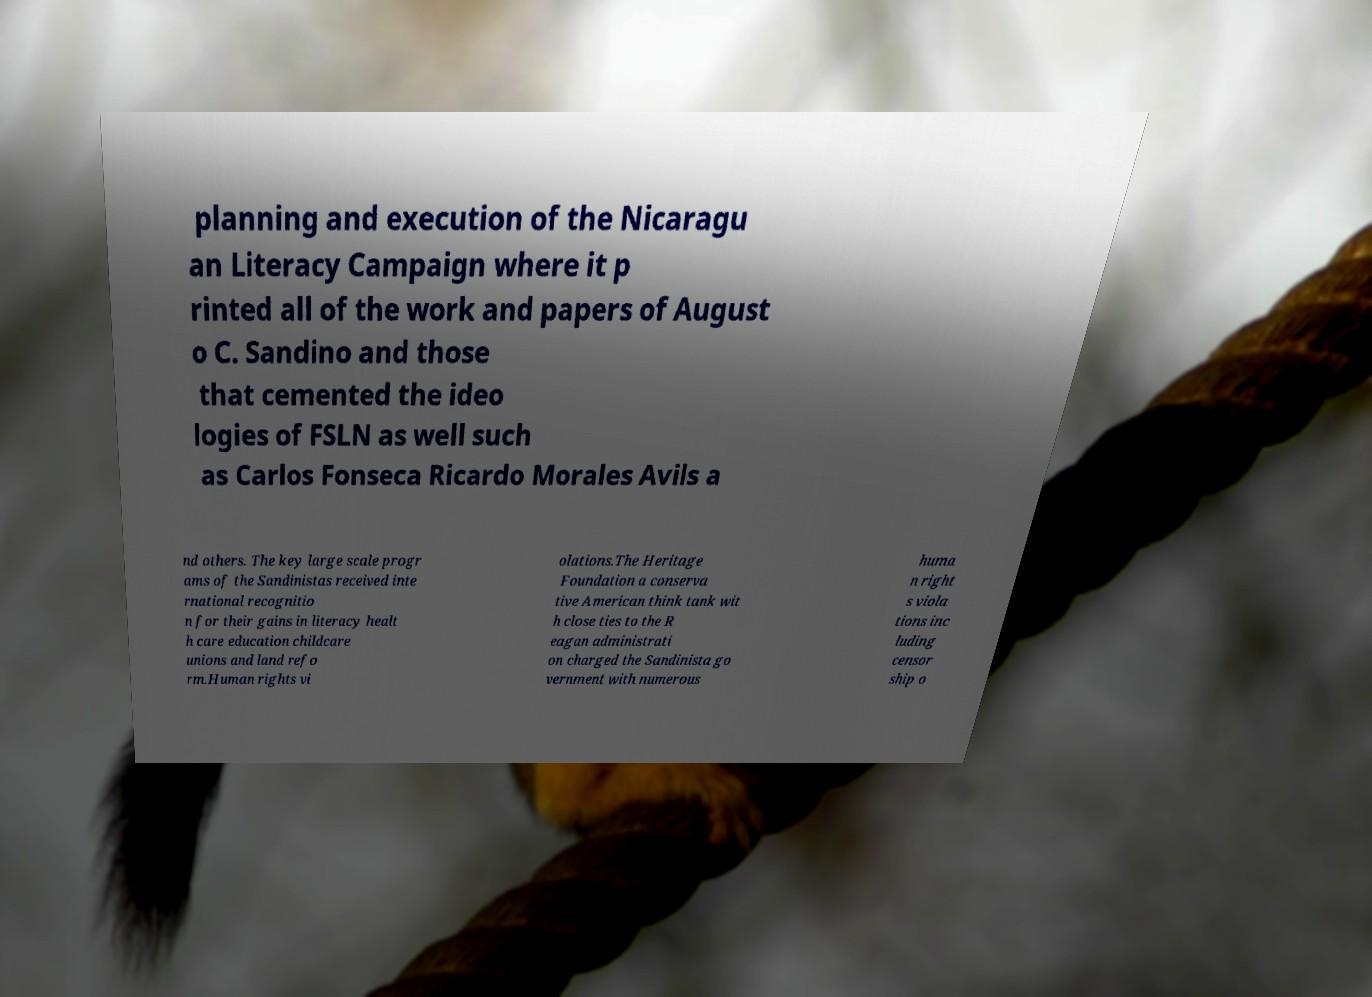Could you extract and type out the text from this image? planning and execution of the Nicaragu an Literacy Campaign where it p rinted all of the work and papers of August o C. Sandino and those that cemented the ideo logies of FSLN as well such as Carlos Fonseca Ricardo Morales Avils a nd others. The key large scale progr ams of the Sandinistas received inte rnational recognitio n for their gains in literacy healt h care education childcare unions and land refo rm.Human rights vi olations.The Heritage Foundation a conserva tive American think tank wit h close ties to the R eagan administrati on charged the Sandinista go vernment with numerous huma n right s viola tions inc luding censor ship o 